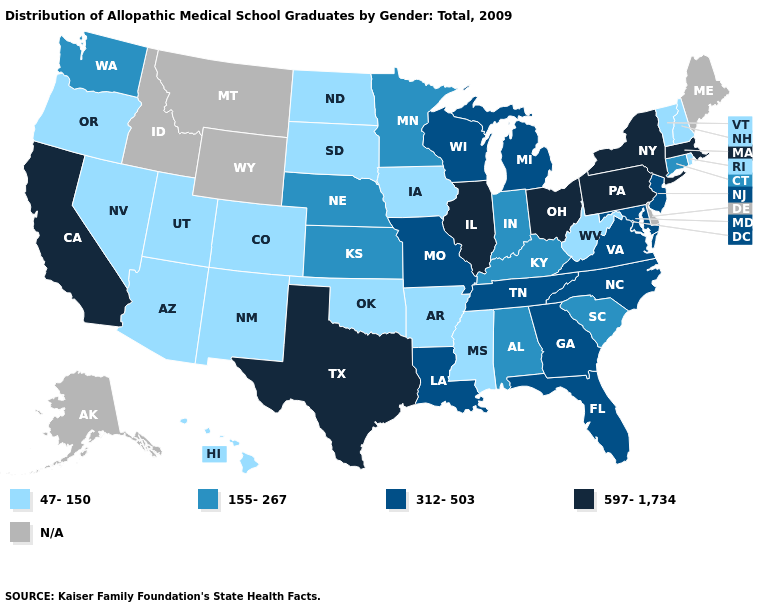What is the value of Iowa?
Keep it brief. 47-150. Name the states that have a value in the range N/A?
Be succinct. Alaska, Delaware, Idaho, Maine, Montana, Wyoming. What is the value of Utah?
Give a very brief answer. 47-150. What is the value of Alabama?
Keep it brief. 155-267. Among the states that border Nebraska , does Iowa have the highest value?
Keep it brief. No. Does Connecticut have the highest value in the USA?
Be succinct. No. Does Ohio have the lowest value in the USA?
Keep it brief. No. Name the states that have a value in the range 597-1,734?
Be succinct. California, Illinois, Massachusetts, New York, Ohio, Pennsylvania, Texas. What is the value of Virginia?
Answer briefly. 312-503. Name the states that have a value in the range 312-503?
Quick response, please. Florida, Georgia, Louisiana, Maryland, Michigan, Missouri, New Jersey, North Carolina, Tennessee, Virginia, Wisconsin. What is the highest value in the USA?
Write a very short answer. 597-1,734. What is the value of Arkansas?
Short answer required. 47-150. Name the states that have a value in the range 155-267?
Write a very short answer. Alabama, Connecticut, Indiana, Kansas, Kentucky, Minnesota, Nebraska, South Carolina, Washington. Name the states that have a value in the range 597-1,734?
Answer briefly. California, Illinois, Massachusetts, New York, Ohio, Pennsylvania, Texas. 